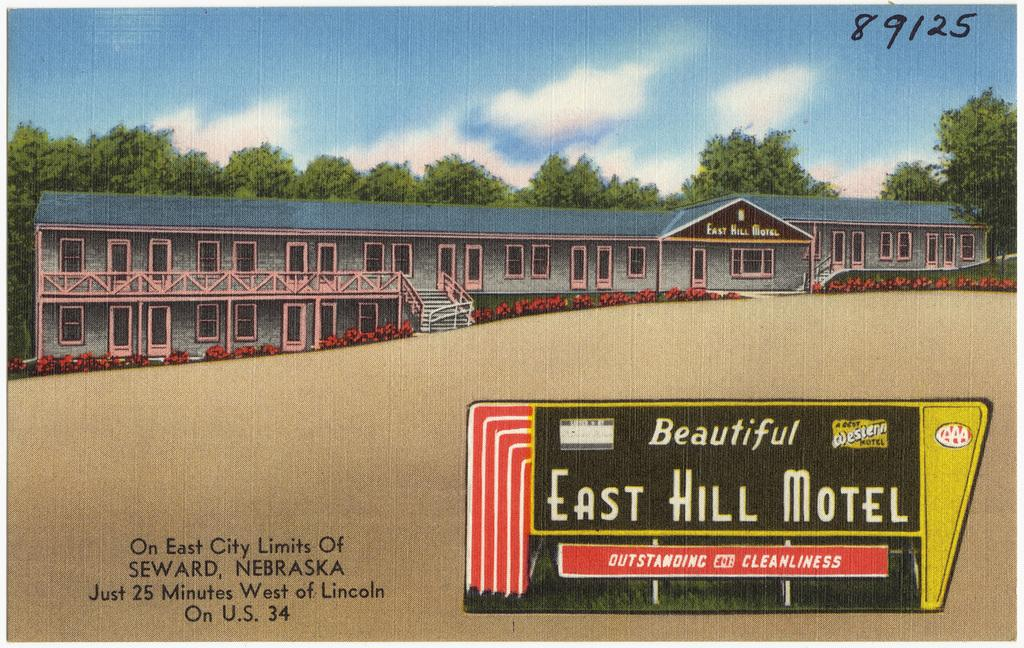Provide a one-sentence caption for the provided image. A painting shows the East Hill Motel in the 80s. 